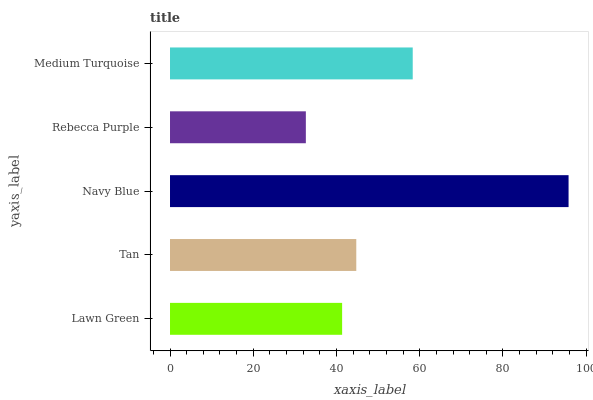Is Rebecca Purple the minimum?
Answer yes or no. Yes. Is Navy Blue the maximum?
Answer yes or no. Yes. Is Tan the minimum?
Answer yes or no. No. Is Tan the maximum?
Answer yes or no. No. Is Tan greater than Lawn Green?
Answer yes or no. Yes. Is Lawn Green less than Tan?
Answer yes or no. Yes. Is Lawn Green greater than Tan?
Answer yes or no. No. Is Tan less than Lawn Green?
Answer yes or no. No. Is Tan the high median?
Answer yes or no. Yes. Is Tan the low median?
Answer yes or no. Yes. Is Navy Blue the high median?
Answer yes or no. No. Is Navy Blue the low median?
Answer yes or no. No. 